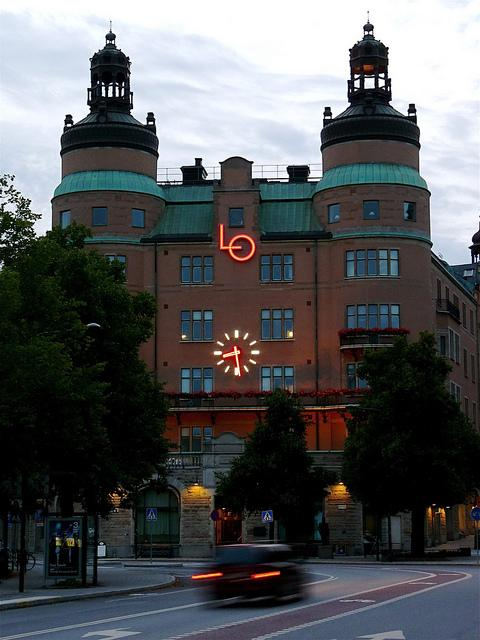What gas causes these lights to glow?

Choices:
A) argon
B) oxygen
C) neon
D) hydrogen neon 